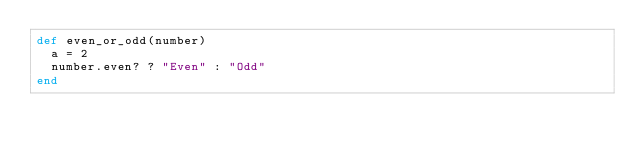Convert code to text. <code><loc_0><loc_0><loc_500><loc_500><_Ruby_>def even_or_odd(number)
  a = 2
  number.even? ? "Even" : "Odd"
end
</code> 